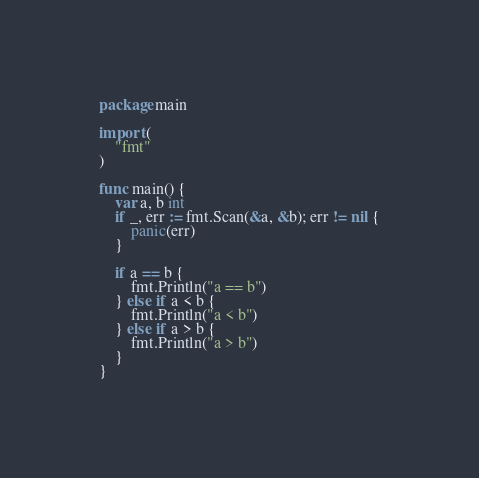<code> <loc_0><loc_0><loc_500><loc_500><_Go_>package main

import (
	"fmt"
)

func main() {
	var a, b int
	if _, err := fmt.Scan(&a, &b); err != nil {
		panic(err)
	}

	if a == b {
		fmt.Println("a == b")
	} else if a < b {
		fmt.Println("a < b")
	} else if a > b {
		fmt.Println("a > b")
	}
}

</code> 